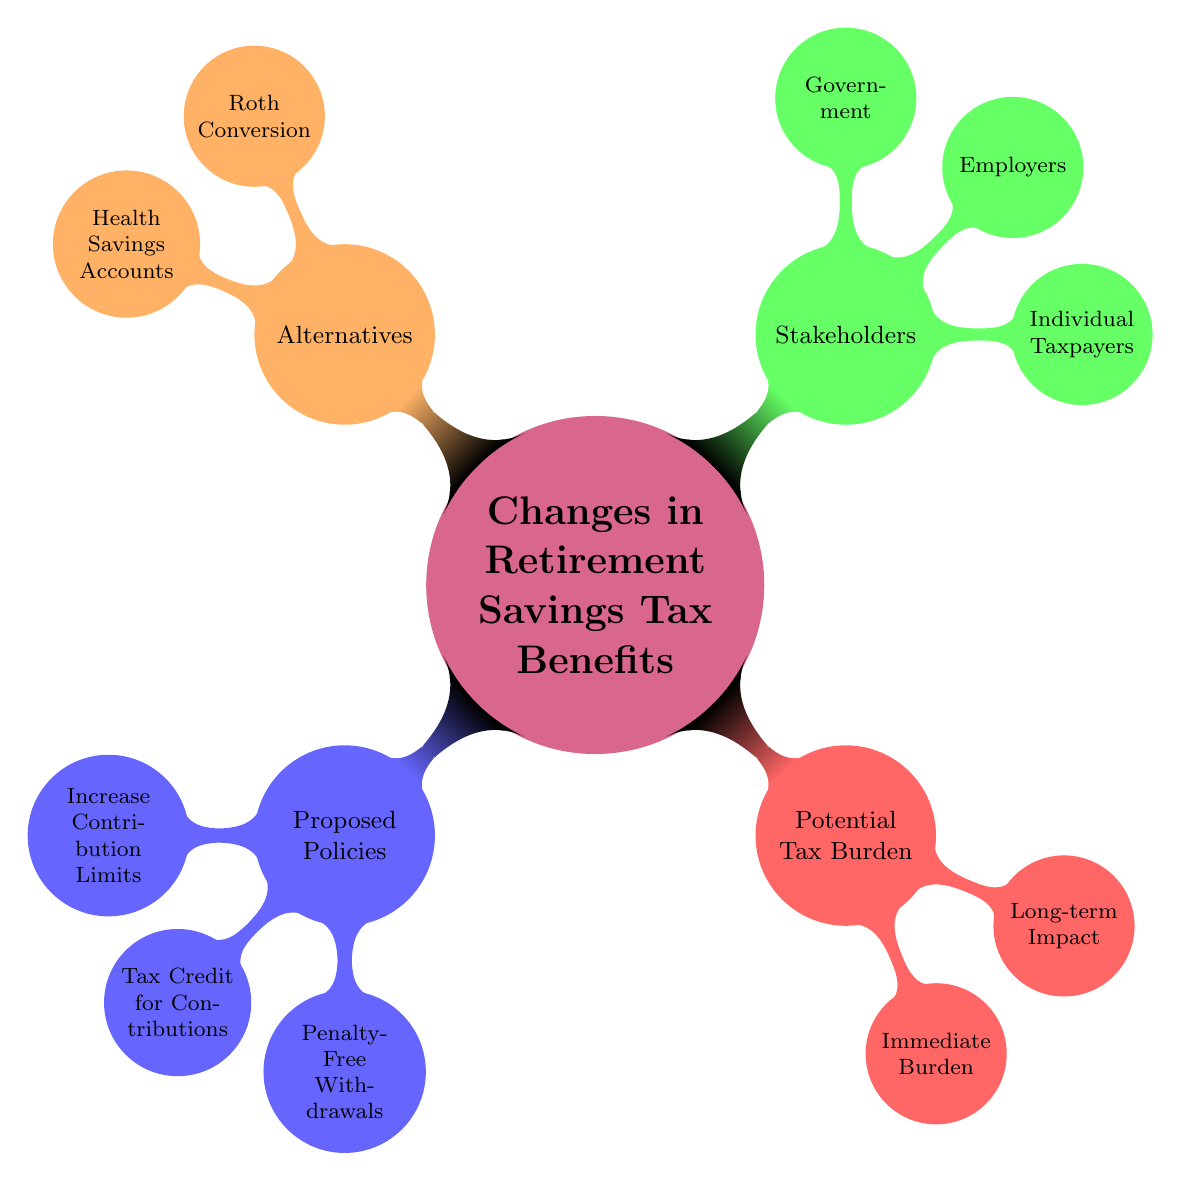What are the proposed policies regarding retirement savings? The main categories are Increase Contribution Limits, Tax Credit for Contributions, and Penalty-Free Withdrawals. These are the top-level nodes under the Proposed Policies section.
Answer: Increase Contribution Limits, Tax Credit for Contributions, Penalty-Free Withdrawals How many immediate burdens are mentioned? Under the Potential Tax Burden section, the Immediate Burden node has two sub-nodes: Increased Taxable Income and Debt Financing. This indicates there are a total of two immediate burdens.
Answer: 2 What is a benefit associated with Emergency Expenses in the Penalty-Free Withdrawals policy? The Penalty-Free Withdrawals policy includes the benefit of allowing withdrawals for medical or financial emergencies. This is explicitly stated under the Emergency Expenses sub-node.
Answer: Allow withdrawals for medical or financial emergencies Which stakeholders are affected by the proposed changes? The stakeholders listed under the Stakeholders section are Individual Taxpayers, Employers, and Government. These represent the groups that will feel the effects of the proposed policies.
Answer: Individual Taxpayers, Employers, Government What is the long-term impact related to Future Tax Rates? The Long-term Impact section highlights uncertainty about future tax rates as a concern for the proposed policies. This indicates that the implications of potential tax changes are a critical point of discussion.
Answer: Uncertainty about future tax rates Which alternative focuses on health-related savings? The Alternative node includes Health Savings Accounts, which specifically addresses tax-advantaged savings related to healthcare costs. This is a pivotal point under the Alternatives section.
Answer: Health Savings Accounts Explain the point related to Government regarding the proposed policies. The Government node highlights the need to balance budgets and provide incentives. This suggests that the government's role includes managing financial implications while encouraging retirement savings.
Answer: Balancing budgets and providing incentives 